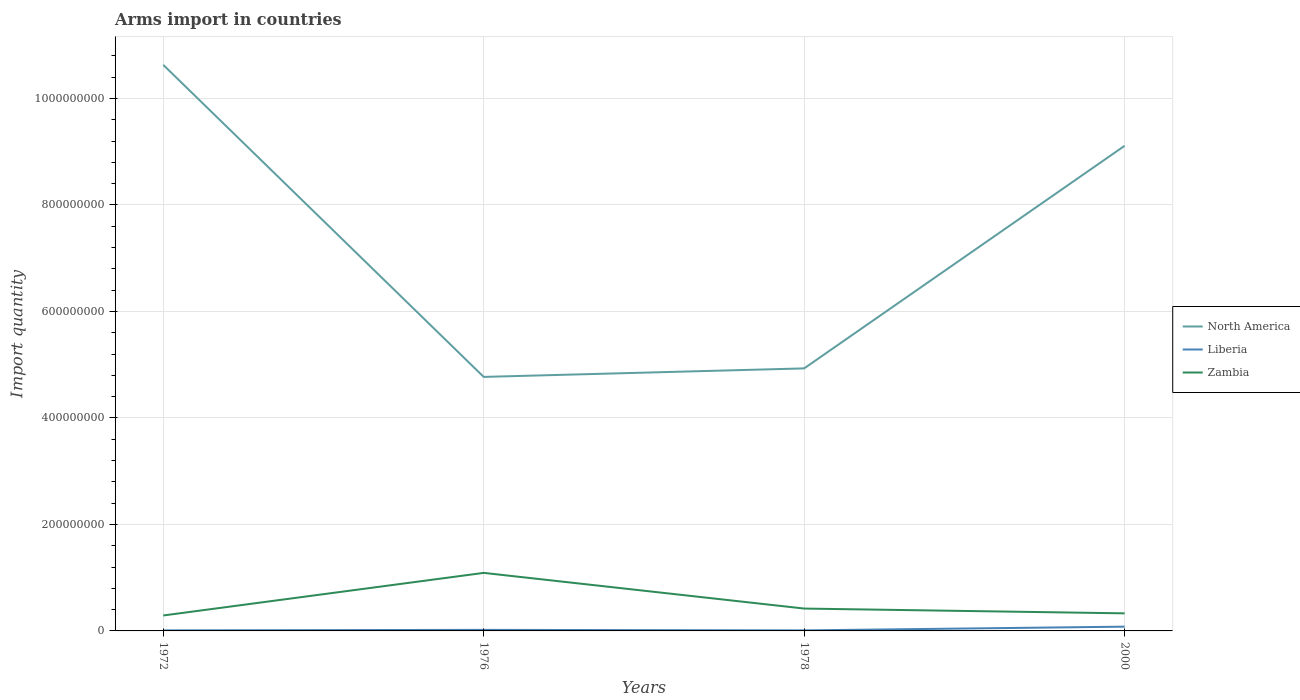How many different coloured lines are there?
Offer a very short reply. 3. Is the number of lines equal to the number of legend labels?
Provide a succinct answer. Yes. Across all years, what is the maximum total arms import in North America?
Ensure brevity in your answer.  4.77e+08. What is the difference between the highest and the second highest total arms import in North America?
Make the answer very short. 5.86e+08. What is the difference between the highest and the lowest total arms import in North America?
Offer a terse response. 2. How many years are there in the graph?
Ensure brevity in your answer.  4. How many legend labels are there?
Offer a terse response. 3. What is the title of the graph?
Give a very brief answer. Arms import in countries. What is the label or title of the Y-axis?
Your answer should be compact. Import quantity. What is the Import quantity of North America in 1972?
Give a very brief answer. 1.06e+09. What is the Import quantity of Zambia in 1972?
Your response must be concise. 2.90e+07. What is the Import quantity of North America in 1976?
Give a very brief answer. 4.77e+08. What is the Import quantity in Liberia in 1976?
Provide a succinct answer. 2.00e+06. What is the Import quantity of Zambia in 1976?
Your response must be concise. 1.09e+08. What is the Import quantity in North America in 1978?
Make the answer very short. 4.93e+08. What is the Import quantity of Zambia in 1978?
Provide a short and direct response. 4.20e+07. What is the Import quantity in North America in 2000?
Provide a succinct answer. 9.11e+08. What is the Import quantity of Zambia in 2000?
Give a very brief answer. 3.30e+07. Across all years, what is the maximum Import quantity of North America?
Ensure brevity in your answer.  1.06e+09. Across all years, what is the maximum Import quantity of Zambia?
Your answer should be very brief. 1.09e+08. Across all years, what is the minimum Import quantity of North America?
Provide a succinct answer. 4.77e+08. Across all years, what is the minimum Import quantity in Liberia?
Ensure brevity in your answer.  1.00e+06. Across all years, what is the minimum Import quantity in Zambia?
Your answer should be very brief. 2.90e+07. What is the total Import quantity of North America in the graph?
Your answer should be compact. 2.94e+09. What is the total Import quantity of Zambia in the graph?
Offer a terse response. 2.13e+08. What is the difference between the Import quantity of North America in 1972 and that in 1976?
Your response must be concise. 5.86e+08. What is the difference between the Import quantity of Zambia in 1972 and that in 1976?
Your answer should be very brief. -8.00e+07. What is the difference between the Import quantity of North America in 1972 and that in 1978?
Make the answer very short. 5.70e+08. What is the difference between the Import quantity in Liberia in 1972 and that in 1978?
Provide a short and direct response. 0. What is the difference between the Import quantity in Zambia in 1972 and that in 1978?
Provide a succinct answer. -1.30e+07. What is the difference between the Import quantity of North America in 1972 and that in 2000?
Your response must be concise. 1.52e+08. What is the difference between the Import quantity of Liberia in 1972 and that in 2000?
Make the answer very short. -7.00e+06. What is the difference between the Import quantity of North America in 1976 and that in 1978?
Offer a very short reply. -1.60e+07. What is the difference between the Import quantity in Zambia in 1976 and that in 1978?
Offer a very short reply. 6.70e+07. What is the difference between the Import quantity of North America in 1976 and that in 2000?
Offer a very short reply. -4.34e+08. What is the difference between the Import quantity of Liberia in 1976 and that in 2000?
Keep it short and to the point. -6.00e+06. What is the difference between the Import quantity in Zambia in 1976 and that in 2000?
Offer a terse response. 7.60e+07. What is the difference between the Import quantity in North America in 1978 and that in 2000?
Ensure brevity in your answer.  -4.18e+08. What is the difference between the Import quantity of Liberia in 1978 and that in 2000?
Your response must be concise. -7.00e+06. What is the difference between the Import quantity in Zambia in 1978 and that in 2000?
Your answer should be compact. 9.00e+06. What is the difference between the Import quantity in North America in 1972 and the Import quantity in Liberia in 1976?
Keep it short and to the point. 1.06e+09. What is the difference between the Import quantity in North America in 1972 and the Import quantity in Zambia in 1976?
Offer a terse response. 9.54e+08. What is the difference between the Import quantity of Liberia in 1972 and the Import quantity of Zambia in 1976?
Offer a terse response. -1.08e+08. What is the difference between the Import quantity in North America in 1972 and the Import quantity in Liberia in 1978?
Offer a very short reply. 1.06e+09. What is the difference between the Import quantity in North America in 1972 and the Import quantity in Zambia in 1978?
Make the answer very short. 1.02e+09. What is the difference between the Import quantity of Liberia in 1972 and the Import quantity of Zambia in 1978?
Provide a short and direct response. -4.10e+07. What is the difference between the Import quantity of North America in 1972 and the Import quantity of Liberia in 2000?
Make the answer very short. 1.06e+09. What is the difference between the Import quantity of North America in 1972 and the Import quantity of Zambia in 2000?
Your answer should be compact. 1.03e+09. What is the difference between the Import quantity in Liberia in 1972 and the Import quantity in Zambia in 2000?
Give a very brief answer. -3.20e+07. What is the difference between the Import quantity of North America in 1976 and the Import quantity of Liberia in 1978?
Provide a short and direct response. 4.76e+08. What is the difference between the Import quantity of North America in 1976 and the Import quantity of Zambia in 1978?
Provide a short and direct response. 4.35e+08. What is the difference between the Import quantity of Liberia in 1976 and the Import quantity of Zambia in 1978?
Provide a short and direct response. -4.00e+07. What is the difference between the Import quantity of North America in 1976 and the Import quantity of Liberia in 2000?
Your answer should be compact. 4.69e+08. What is the difference between the Import quantity in North America in 1976 and the Import quantity in Zambia in 2000?
Offer a terse response. 4.44e+08. What is the difference between the Import quantity in Liberia in 1976 and the Import quantity in Zambia in 2000?
Your response must be concise. -3.10e+07. What is the difference between the Import quantity in North America in 1978 and the Import quantity in Liberia in 2000?
Provide a succinct answer. 4.85e+08. What is the difference between the Import quantity of North America in 1978 and the Import quantity of Zambia in 2000?
Your answer should be compact. 4.60e+08. What is the difference between the Import quantity of Liberia in 1978 and the Import quantity of Zambia in 2000?
Ensure brevity in your answer.  -3.20e+07. What is the average Import quantity in North America per year?
Your answer should be compact. 7.36e+08. What is the average Import quantity of Zambia per year?
Provide a succinct answer. 5.32e+07. In the year 1972, what is the difference between the Import quantity of North America and Import quantity of Liberia?
Your answer should be very brief. 1.06e+09. In the year 1972, what is the difference between the Import quantity in North America and Import quantity in Zambia?
Your response must be concise. 1.03e+09. In the year 1972, what is the difference between the Import quantity of Liberia and Import quantity of Zambia?
Provide a succinct answer. -2.80e+07. In the year 1976, what is the difference between the Import quantity in North America and Import quantity in Liberia?
Make the answer very short. 4.75e+08. In the year 1976, what is the difference between the Import quantity of North America and Import quantity of Zambia?
Make the answer very short. 3.68e+08. In the year 1976, what is the difference between the Import quantity of Liberia and Import quantity of Zambia?
Provide a succinct answer. -1.07e+08. In the year 1978, what is the difference between the Import quantity of North America and Import quantity of Liberia?
Provide a succinct answer. 4.92e+08. In the year 1978, what is the difference between the Import quantity in North America and Import quantity in Zambia?
Ensure brevity in your answer.  4.51e+08. In the year 1978, what is the difference between the Import quantity of Liberia and Import quantity of Zambia?
Give a very brief answer. -4.10e+07. In the year 2000, what is the difference between the Import quantity in North America and Import quantity in Liberia?
Offer a terse response. 9.03e+08. In the year 2000, what is the difference between the Import quantity in North America and Import quantity in Zambia?
Your response must be concise. 8.78e+08. In the year 2000, what is the difference between the Import quantity of Liberia and Import quantity of Zambia?
Your response must be concise. -2.50e+07. What is the ratio of the Import quantity in North America in 1972 to that in 1976?
Ensure brevity in your answer.  2.23. What is the ratio of the Import quantity in Zambia in 1972 to that in 1976?
Ensure brevity in your answer.  0.27. What is the ratio of the Import quantity in North America in 1972 to that in 1978?
Your answer should be very brief. 2.16. What is the ratio of the Import quantity in Liberia in 1972 to that in 1978?
Give a very brief answer. 1. What is the ratio of the Import quantity of Zambia in 1972 to that in 1978?
Ensure brevity in your answer.  0.69. What is the ratio of the Import quantity in North America in 1972 to that in 2000?
Provide a short and direct response. 1.17. What is the ratio of the Import quantity of Liberia in 1972 to that in 2000?
Your response must be concise. 0.12. What is the ratio of the Import quantity in Zambia in 1972 to that in 2000?
Keep it short and to the point. 0.88. What is the ratio of the Import quantity in North America in 1976 to that in 1978?
Give a very brief answer. 0.97. What is the ratio of the Import quantity of Zambia in 1976 to that in 1978?
Your answer should be very brief. 2.6. What is the ratio of the Import quantity in North America in 1976 to that in 2000?
Offer a terse response. 0.52. What is the ratio of the Import quantity of Zambia in 1976 to that in 2000?
Give a very brief answer. 3.3. What is the ratio of the Import quantity in North America in 1978 to that in 2000?
Your answer should be very brief. 0.54. What is the ratio of the Import quantity in Zambia in 1978 to that in 2000?
Your response must be concise. 1.27. What is the difference between the highest and the second highest Import quantity of North America?
Provide a short and direct response. 1.52e+08. What is the difference between the highest and the second highest Import quantity of Liberia?
Keep it short and to the point. 6.00e+06. What is the difference between the highest and the second highest Import quantity in Zambia?
Your answer should be compact. 6.70e+07. What is the difference between the highest and the lowest Import quantity of North America?
Your answer should be compact. 5.86e+08. What is the difference between the highest and the lowest Import quantity in Zambia?
Your answer should be very brief. 8.00e+07. 